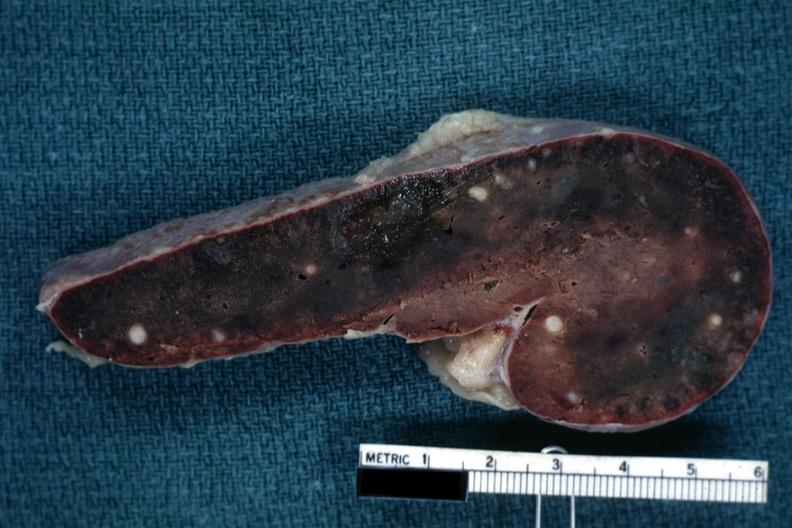s fixed tissue cut surface congested parenchyma with obvious granulomas?
Answer the question using a single word or phrase. Yes 